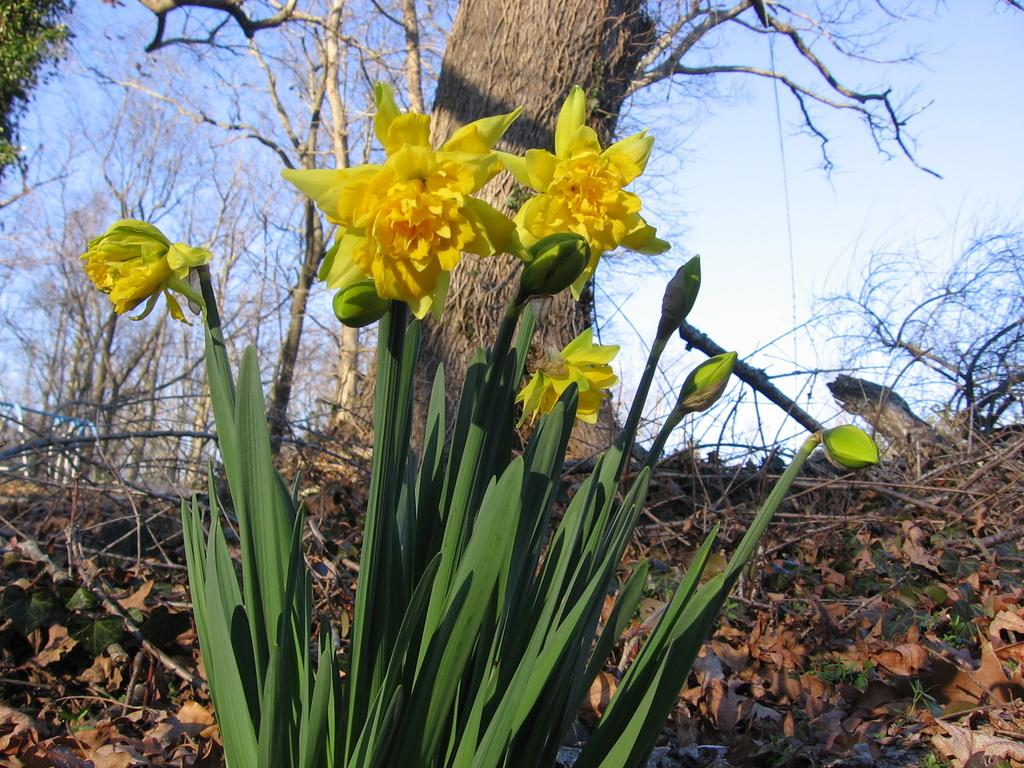What type of vegetation can be seen in the image? There are plants and trees in the image. Are there any specific features of the plants in the image? Yes, there are flowers in the image. What else can be found on the ground in the image? Dry leaves are present in the image. What is visible at the top of the image? The sky is visible at the top of the image. What type of friction can be observed between the squirrel and the peace sign in the image? There is no squirrel or peace sign present in the image, so no such friction can be observed. 